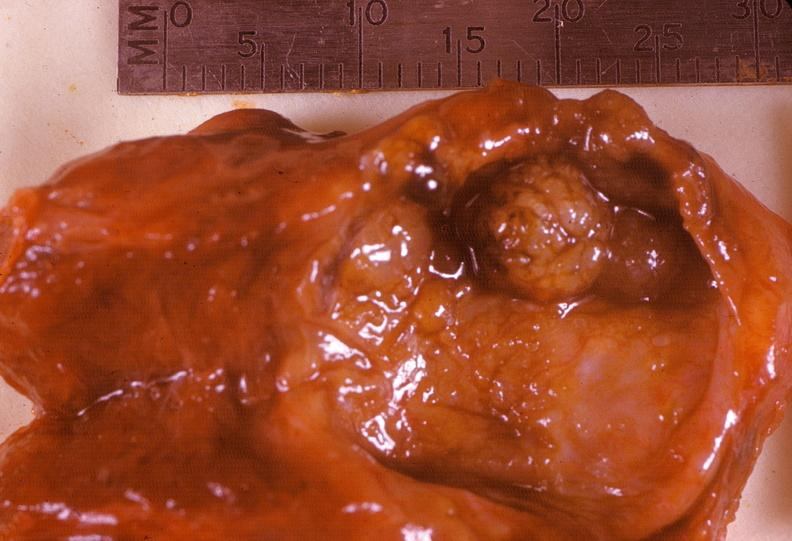s chronic ischemia present?
Answer the question using a single word or phrase. No 